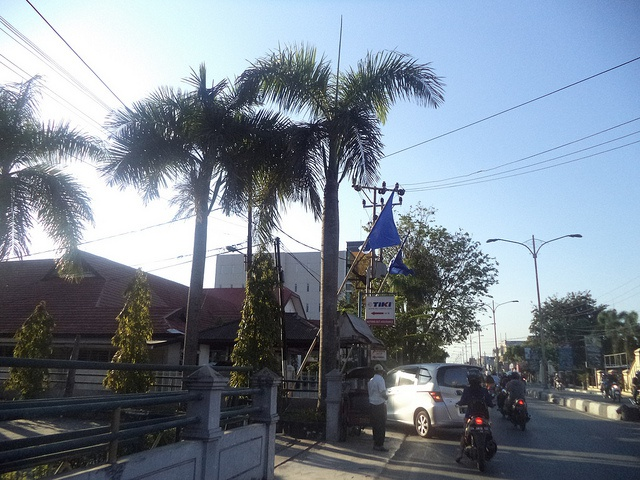Describe the objects in this image and their specific colors. I can see car in lightblue, gray, ivory, darkgray, and black tones, motorcycle in lightblue, black, gray, and maroon tones, people in lightblue, black, and gray tones, people in lightblue, black, and gray tones, and people in lightblue, black, and gray tones in this image. 